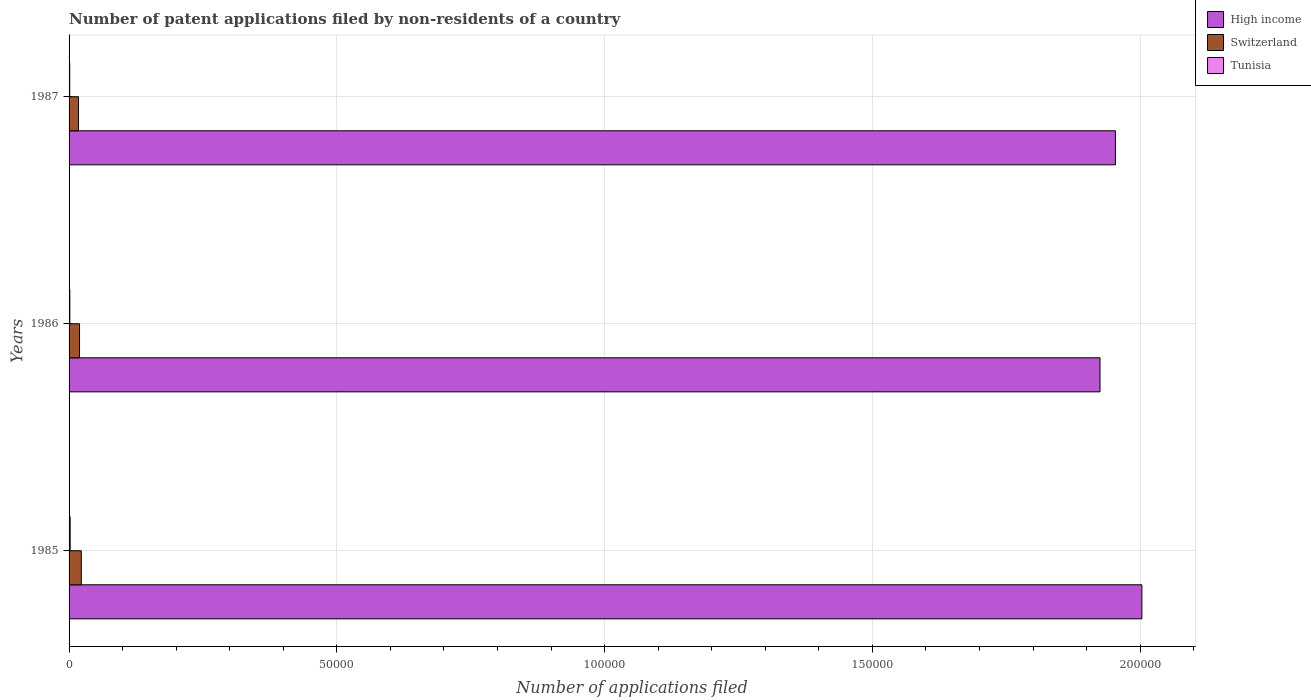How many groups of bars are there?
Offer a terse response. 3. How many bars are there on the 1st tick from the top?
Offer a very short reply. 3. What is the number of applications filed in High income in 1987?
Provide a short and direct response. 1.95e+05. Across all years, what is the maximum number of applications filed in Switzerland?
Make the answer very short. 2281. Across all years, what is the minimum number of applications filed in High income?
Your answer should be compact. 1.93e+05. What is the total number of applications filed in Tunisia in the graph?
Keep it short and to the point. 461. What is the difference between the number of applications filed in High income in 1985 and that in 1987?
Ensure brevity in your answer.  4940. What is the difference between the number of applications filed in Switzerland in 1985 and the number of applications filed in Tunisia in 1986?
Your response must be concise. 2142. What is the average number of applications filed in High income per year?
Your answer should be very brief. 1.96e+05. In the year 1987, what is the difference between the number of applications filed in Tunisia and number of applications filed in Switzerland?
Your response must be concise. -1644. What is the ratio of the number of applications filed in High income in 1985 to that in 1986?
Your answer should be compact. 1.04. Is the difference between the number of applications filed in Tunisia in 1985 and 1987 greater than the difference between the number of applications filed in Switzerland in 1985 and 1987?
Keep it short and to the point. No. What is the difference between the highest and the second highest number of applications filed in Tunisia?
Make the answer very short. 63. What is the difference between the highest and the lowest number of applications filed in High income?
Your answer should be compact. 7817. Is the sum of the number of applications filed in High income in 1985 and 1987 greater than the maximum number of applications filed in Tunisia across all years?
Ensure brevity in your answer.  Yes. What does the 2nd bar from the top in 1987 represents?
Your answer should be compact. Switzerland. What does the 3rd bar from the bottom in 1986 represents?
Give a very brief answer. Tunisia. Is it the case that in every year, the sum of the number of applications filed in Tunisia and number of applications filed in Switzerland is greater than the number of applications filed in High income?
Make the answer very short. No. Are all the bars in the graph horizontal?
Offer a terse response. Yes. How many years are there in the graph?
Make the answer very short. 3. What is the difference between two consecutive major ticks on the X-axis?
Your answer should be very brief. 5.00e+04. Does the graph contain grids?
Keep it short and to the point. Yes. Where does the legend appear in the graph?
Your response must be concise. Top right. What is the title of the graph?
Your response must be concise. Number of patent applications filed by non-residents of a country. Does "Malawi" appear as one of the legend labels in the graph?
Provide a succinct answer. No. What is the label or title of the X-axis?
Offer a terse response. Number of applications filed. What is the label or title of the Y-axis?
Provide a short and direct response. Years. What is the Number of applications filed in High income in 1985?
Keep it short and to the point. 2.00e+05. What is the Number of applications filed in Switzerland in 1985?
Offer a terse response. 2281. What is the Number of applications filed in Tunisia in 1985?
Keep it short and to the point. 202. What is the Number of applications filed in High income in 1986?
Offer a terse response. 1.93e+05. What is the Number of applications filed of Switzerland in 1986?
Ensure brevity in your answer.  1954. What is the Number of applications filed of Tunisia in 1986?
Give a very brief answer. 139. What is the Number of applications filed in High income in 1987?
Provide a succinct answer. 1.95e+05. What is the Number of applications filed in Switzerland in 1987?
Provide a succinct answer. 1764. What is the Number of applications filed of Tunisia in 1987?
Provide a short and direct response. 120. Across all years, what is the maximum Number of applications filed of High income?
Give a very brief answer. 2.00e+05. Across all years, what is the maximum Number of applications filed of Switzerland?
Offer a very short reply. 2281. Across all years, what is the maximum Number of applications filed of Tunisia?
Your answer should be compact. 202. Across all years, what is the minimum Number of applications filed in High income?
Provide a short and direct response. 1.93e+05. Across all years, what is the minimum Number of applications filed of Switzerland?
Your answer should be very brief. 1764. Across all years, what is the minimum Number of applications filed in Tunisia?
Make the answer very short. 120. What is the total Number of applications filed of High income in the graph?
Provide a short and direct response. 5.88e+05. What is the total Number of applications filed in Switzerland in the graph?
Ensure brevity in your answer.  5999. What is the total Number of applications filed in Tunisia in the graph?
Give a very brief answer. 461. What is the difference between the Number of applications filed of High income in 1985 and that in 1986?
Keep it short and to the point. 7817. What is the difference between the Number of applications filed of Switzerland in 1985 and that in 1986?
Offer a very short reply. 327. What is the difference between the Number of applications filed in Tunisia in 1985 and that in 1986?
Make the answer very short. 63. What is the difference between the Number of applications filed of High income in 1985 and that in 1987?
Offer a very short reply. 4940. What is the difference between the Number of applications filed of Switzerland in 1985 and that in 1987?
Your answer should be compact. 517. What is the difference between the Number of applications filed of High income in 1986 and that in 1987?
Your answer should be very brief. -2877. What is the difference between the Number of applications filed of Switzerland in 1986 and that in 1987?
Ensure brevity in your answer.  190. What is the difference between the Number of applications filed of Tunisia in 1986 and that in 1987?
Make the answer very short. 19. What is the difference between the Number of applications filed in High income in 1985 and the Number of applications filed in Switzerland in 1986?
Your response must be concise. 1.98e+05. What is the difference between the Number of applications filed of High income in 1985 and the Number of applications filed of Tunisia in 1986?
Provide a succinct answer. 2.00e+05. What is the difference between the Number of applications filed in Switzerland in 1985 and the Number of applications filed in Tunisia in 1986?
Your answer should be compact. 2142. What is the difference between the Number of applications filed in High income in 1985 and the Number of applications filed in Switzerland in 1987?
Provide a short and direct response. 1.99e+05. What is the difference between the Number of applications filed in High income in 1985 and the Number of applications filed in Tunisia in 1987?
Your answer should be compact. 2.00e+05. What is the difference between the Number of applications filed in Switzerland in 1985 and the Number of applications filed in Tunisia in 1987?
Your response must be concise. 2161. What is the difference between the Number of applications filed in High income in 1986 and the Number of applications filed in Switzerland in 1987?
Your answer should be compact. 1.91e+05. What is the difference between the Number of applications filed in High income in 1986 and the Number of applications filed in Tunisia in 1987?
Keep it short and to the point. 1.92e+05. What is the difference between the Number of applications filed in Switzerland in 1986 and the Number of applications filed in Tunisia in 1987?
Ensure brevity in your answer.  1834. What is the average Number of applications filed of High income per year?
Ensure brevity in your answer.  1.96e+05. What is the average Number of applications filed of Switzerland per year?
Ensure brevity in your answer.  1999.67. What is the average Number of applications filed of Tunisia per year?
Provide a short and direct response. 153.67. In the year 1985, what is the difference between the Number of applications filed in High income and Number of applications filed in Switzerland?
Make the answer very short. 1.98e+05. In the year 1985, what is the difference between the Number of applications filed in High income and Number of applications filed in Tunisia?
Provide a succinct answer. 2.00e+05. In the year 1985, what is the difference between the Number of applications filed of Switzerland and Number of applications filed of Tunisia?
Provide a succinct answer. 2079. In the year 1986, what is the difference between the Number of applications filed in High income and Number of applications filed in Switzerland?
Your answer should be very brief. 1.91e+05. In the year 1986, what is the difference between the Number of applications filed in High income and Number of applications filed in Tunisia?
Make the answer very short. 1.92e+05. In the year 1986, what is the difference between the Number of applications filed in Switzerland and Number of applications filed in Tunisia?
Ensure brevity in your answer.  1815. In the year 1987, what is the difference between the Number of applications filed of High income and Number of applications filed of Switzerland?
Provide a short and direct response. 1.94e+05. In the year 1987, what is the difference between the Number of applications filed in High income and Number of applications filed in Tunisia?
Give a very brief answer. 1.95e+05. In the year 1987, what is the difference between the Number of applications filed in Switzerland and Number of applications filed in Tunisia?
Give a very brief answer. 1644. What is the ratio of the Number of applications filed of High income in 1985 to that in 1986?
Your answer should be compact. 1.04. What is the ratio of the Number of applications filed in Switzerland in 1985 to that in 1986?
Your answer should be very brief. 1.17. What is the ratio of the Number of applications filed in Tunisia in 1985 to that in 1986?
Provide a short and direct response. 1.45. What is the ratio of the Number of applications filed in High income in 1985 to that in 1987?
Offer a terse response. 1.03. What is the ratio of the Number of applications filed in Switzerland in 1985 to that in 1987?
Keep it short and to the point. 1.29. What is the ratio of the Number of applications filed of Tunisia in 1985 to that in 1987?
Provide a succinct answer. 1.68. What is the ratio of the Number of applications filed in Switzerland in 1986 to that in 1987?
Offer a terse response. 1.11. What is the ratio of the Number of applications filed in Tunisia in 1986 to that in 1987?
Your response must be concise. 1.16. What is the difference between the highest and the second highest Number of applications filed in High income?
Keep it short and to the point. 4940. What is the difference between the highest and the second highest Number of applications filed of Switzerland?
Your answer should be very brief. 327. What is the difference between the highest and the lowest Number of applications filed in High income?
Give a very brief answer. 7817. What is the difference between the highest and the lowest Number of applications filed in Switzerland?
Make the answer very short. 517. What is the difference between the highest and the lowest Number of applications filed of Tunisia?
Make the answer very short. 82. 